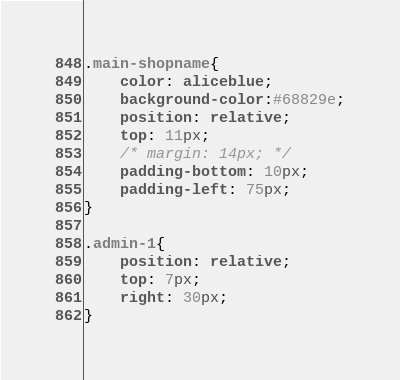Convert code to text. <code><loc_0><loc_0><loc_500><loc_500><_CSS_>.main-shopname{
    color: aliceblue;
    background-color:#68829e;
    position: relative;
    top: 11px;
    /* margin: 14px; */
    padding-bottom: 10px;
    padding-left: 75px;
}

.admin-1{
    position: relative;
    top: 7px;
    right: 30px;
}
</code> 